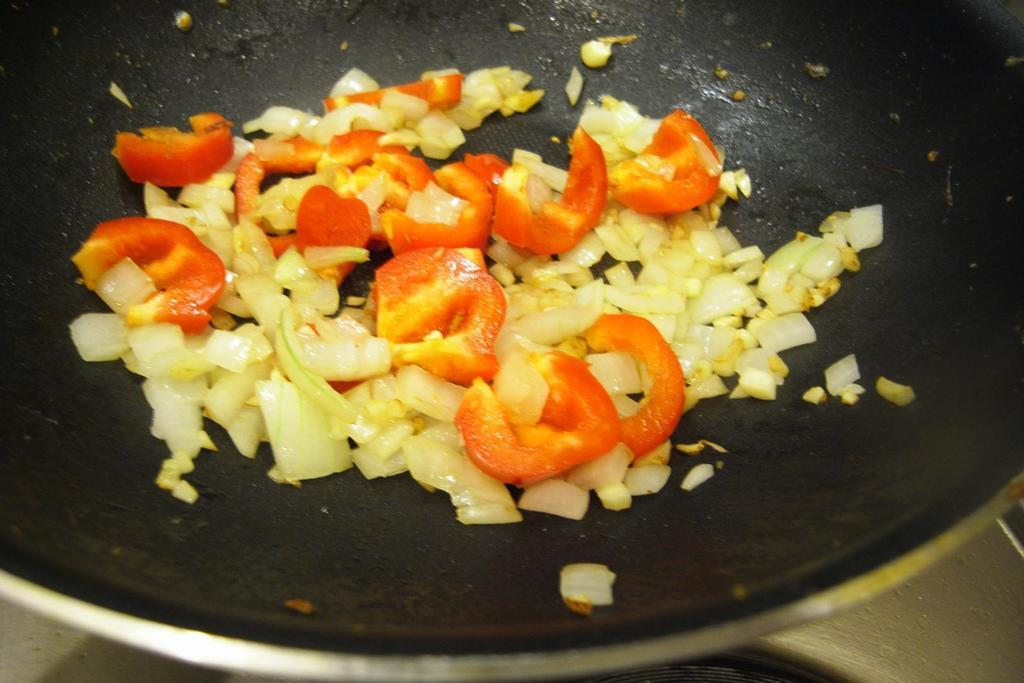What type of food can be seen in the image? There are vegetables in the image. Can you name some specific vegetables that are visible? The vegetables include tomatoes and cabbage. Where are the vegetables placed in the image? The vegetables are placed on a black fry pan. What type of vase is holding the vegetables in the image? There is no vase present in the image; the vegetables are placed on a black fry pan. 